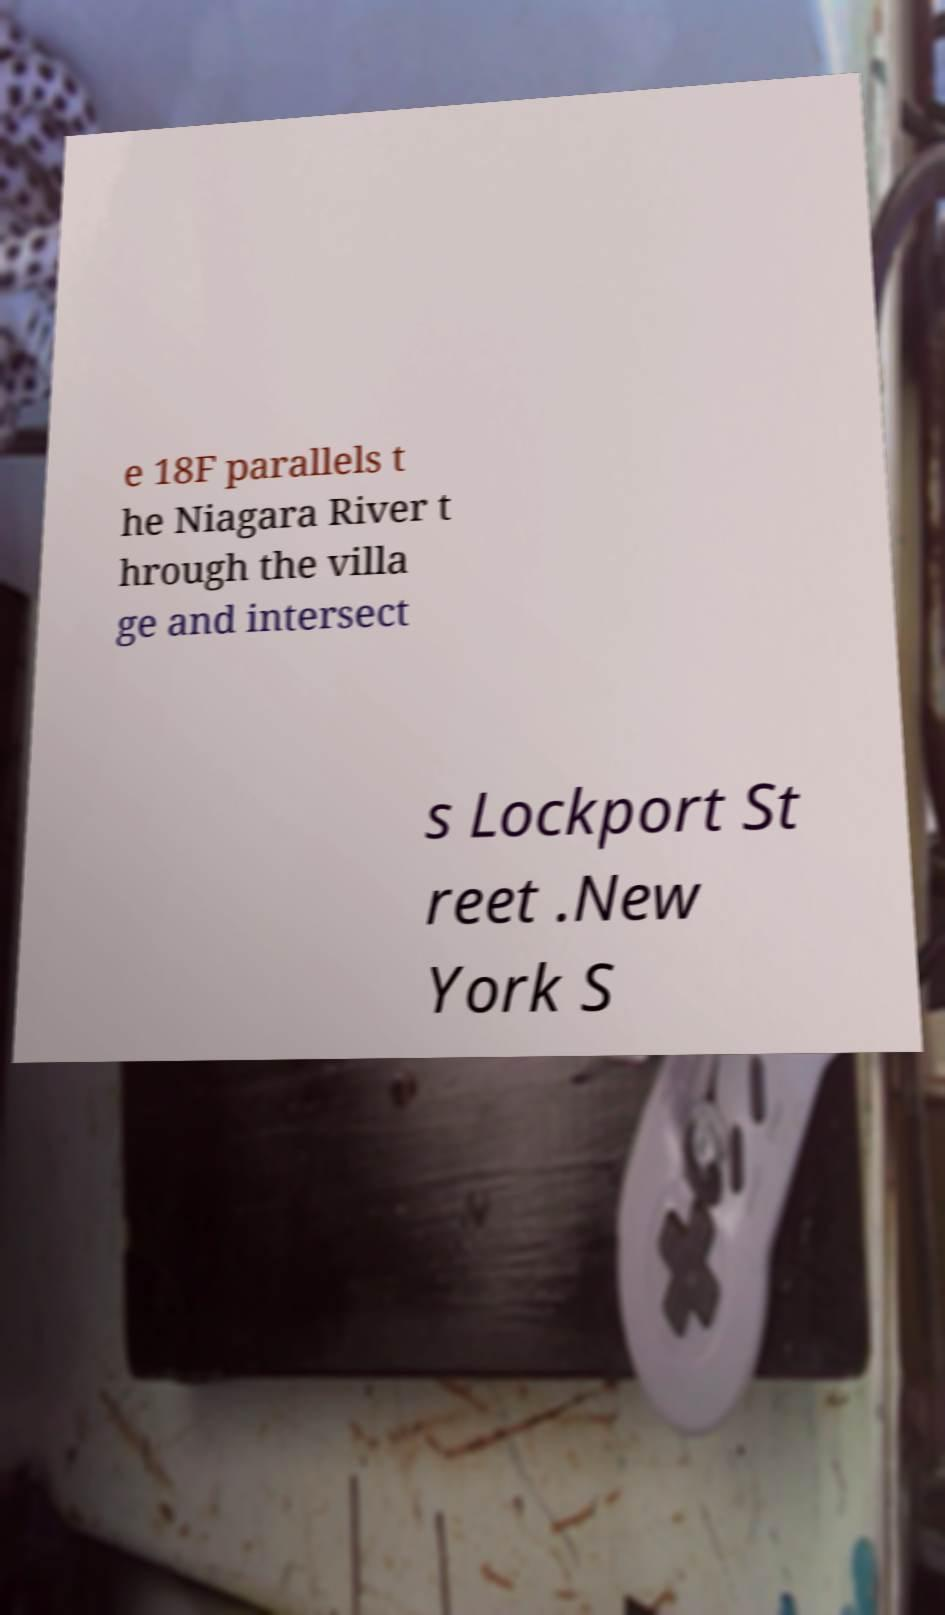For documentation purposes, I need the text within this image transcribed. Could you provide that? e 18F parallels t he Niagara River t hrough the villa ge and intersect s Lockport St reet .New York S 